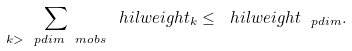Convert formula to latex. <formula><loc_0><loc_0><loc_500><loc_500>\sum _ { k > \ p d i m ^ { \ } m o b s } \ h i l w e i g h t _ { k } \leq \ h i l w e i g h t _ { \ p d i m } .</formula> 